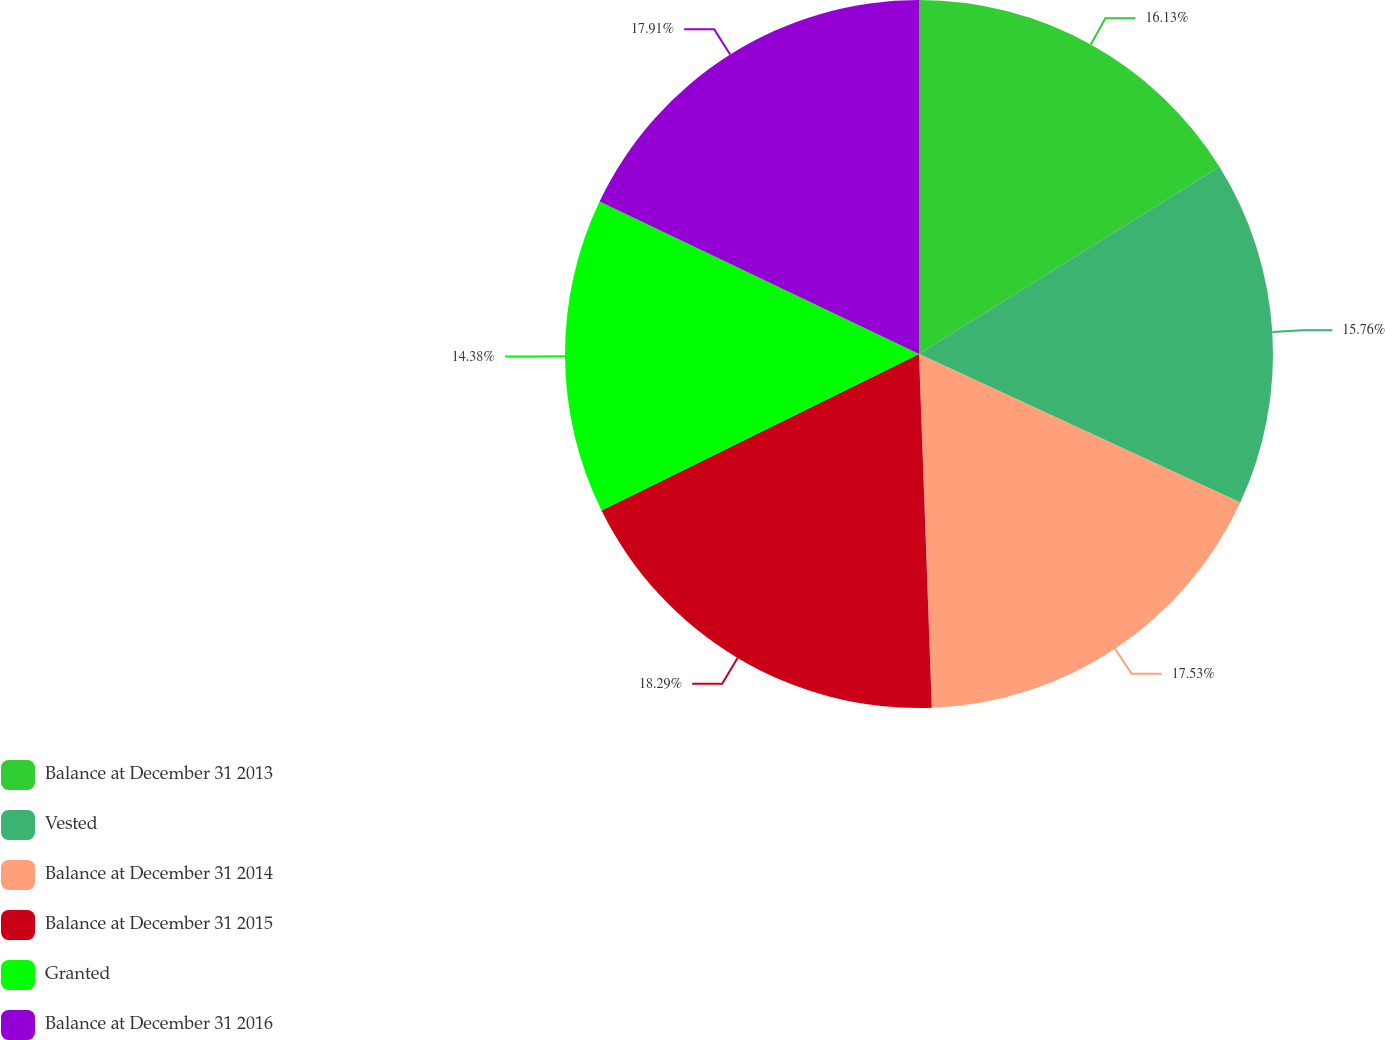<chart> <loc_0><loc_0><loc_500><loc_500><pie_chart><fcel>Balance at December 31 2013<fcel>Vested<fcel>Balance at December 31 2014<fcel>Balance at December 31 2015<fcel>Granted<fcel>Balance at December 31 2016<nl><fcel>16.13%<fcel>15.76%<fcel>17.53%<fcel>18.28%<fcel>14.38%<fcel>17.91%<nl></chart> 